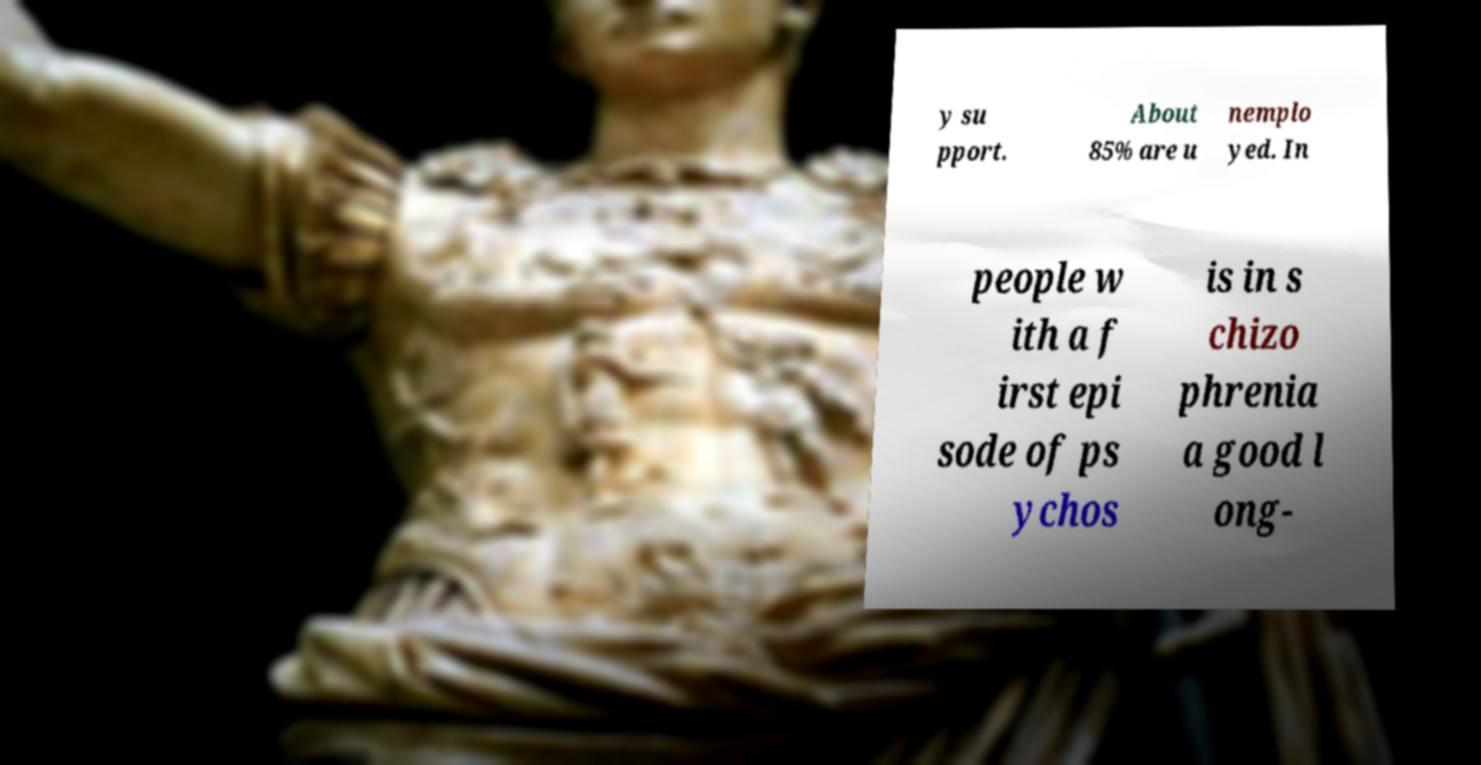There's text embedded in this image that I need extracted. Can you transcribe it verbatim? y su pport. About 85% are u nemplo yed. In people w ith a f irst epi sode of ps ychos is in s chizo phrenia a good l ong- 